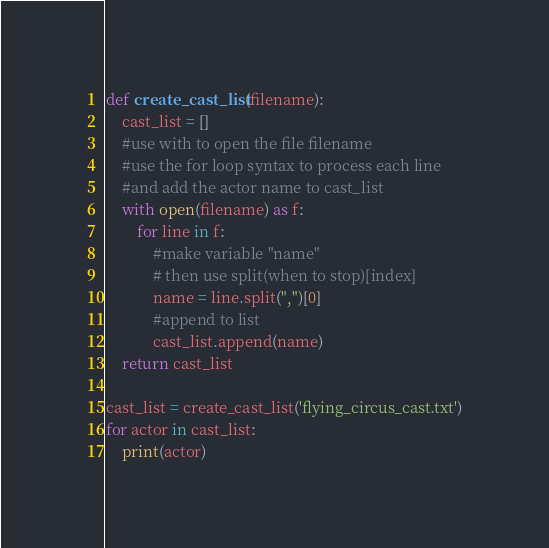<code> <loc_0><loc_0><loc_500><loc_500><_Python_>def create_cast_list(filename):
    cast_list = []
    #use with to open the file filename
    #use the for loop syntax to process each line
    #and add the actor name to cast_list
    with open(filename) as f:
        for line in f:
            #make variable "name"
            # then use split(when to stop)[index]
            name = line.split(",")[0]
            #append to list
            cast_list.append(name)
    return cast_list

cast_list = create_cast_list('flying_circus_cast.txt')
for actor in cast_list:
    print(actor)</code> 